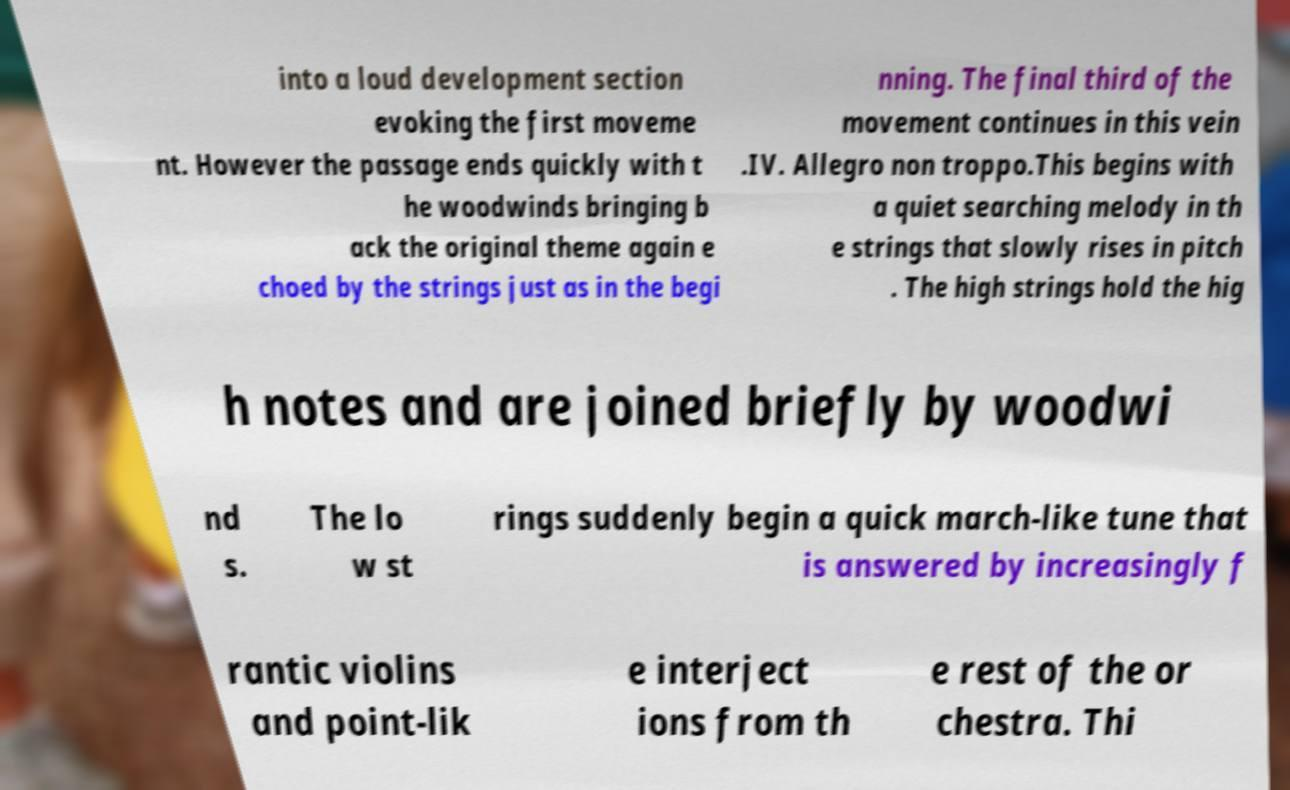There's text embedded in this image that I need extracted. Can you transcribe it verbatim? into a loud development section evoking the first moveme nt. However the passage ends quickly with t he woodwinds bringing b ack the original theme again e choed by the strings just as in the begi nning. The final third of the movement continues in this vein .IV. Allegro non troppo.This begins with a quiet searching melody in th e strings that slowly rises in pitch . The high strings hold the hig h notes and are joined briefly by woodwi nd s. The lo w st rings suddenly begin a quick march-like tune that is answered by increasingly f rantic violins and point-lik e interject ions from th e rest of the or chestra. Thi 